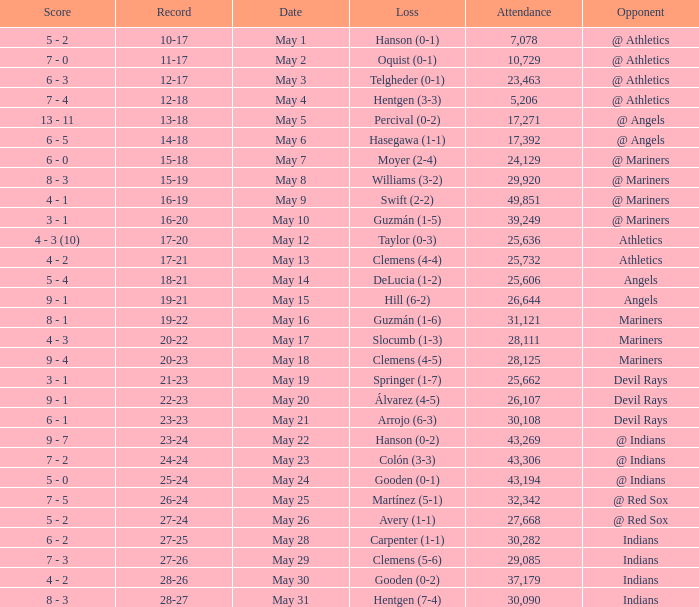Parse the full table. {'header': ['Score', 'Record', 'Date', 'Loss', 'Attendance', 'Opponent'], 'rows': [['5 - 2', '10-17', 'May 1', 'Hanson (0-1)', '7,078', '@ Athletics'], ['7 - 0', '11-17', 'May 2', 'Oquist (0-1)', '10,729', '@ Athletics'], ['6 - 3', '12-17', 'May 3', 'Telgheder (0-1)', '23,463', '@ Athletics'], ['7 - 4', '12-18', 'May 4', 'Hentgen (3-3)', '5,206', '@ Athletics'], ['13 - 11', '13-18', 'May 5', 'Percival (0-2)', '17,271', '@ Angels'], ['6 - 5', '14-18', 'May 6', 'Hasegawa (1-1)', '17,392', '@ Angels'], ['6 - 0', '15-18', 'May 7', 'Moyer (2-4)', '24,129', '@ Mariners'], ['8 - 3', '15-19', 'May 8', 'Williams (3-2)', '29,920', '@ Mariners'], ['4 - 1', '16-19', 'May 9', 'Swift (2-2)', '49,851', '@ Mariners'], ['3 - 1', '16-20', 'May 10', 'Guzmán (1-5)', '39,249', '@ Mariners'], ['4 - 3 (10)', '17-20', 'May 12', 'Taylor (0-3)', '25,636', 'Athletics'], ['4 - 2', '17-21', 'May 13', 'Clemens (4-4)', '25,732', 'Athletics'], ['5 - 4', '18-21', 'May 14', 'DeLucia (1-2)', '25,606', 'Angels'], ['9 - 1', '19-21', 'May 15', 'Hill (6-2)', '26,644', 'Angels'], ['8 - 1', '19-22', 'May 16', 'Guzmán (1-6)', '31,121', 'Mariners'], ['4 - 3', '20-22', 'May 17', 'Slocumb (1-3)', '28,111', 'Mariners'], ['9 - 4', '20-23', 'May 18', 'Clemens (4-5)', '28,125', 'Mariners'], ['3 - 1', '21-23', 'May 19', 'Springer (1-7)', '25,662', 'Devil Rays'], ['9 - 1', '22-23', 'May 20', 'Álvarez (4-5)', '26,107', 'Devil Rays'], ['6 - 1', '23-23', 'May 21', 'Arrojo (6-3)', '30,108', 'Devil Rays'], ['9 - 7', '23-24', 'May 22', 'Hanson (0-2)', '43,269', '@ Indians'], ['7 - 2', '24-24', 'May 23', 'Colón (3-3)', '43,306', '@ Indians'], ['5 - 0', '25-24', 'May 24', 'Gooden (0-1)', '43,194', '@ Indians'], ['7 - 5', '26-24', 'May 25', 'Martínez (5-1)', '32,342', '@ Red Sox'], ['5 - 2', '27-24', 'May 26', 'Avery (1-1)', '27,668', '@ Red Sox'], ['6 - 2', '27-25', 'May 28', 'Carpenter (1-1)', '30,282', 'Indians'], ['7 - 3', '27-26', 'May 29', 'Clemens (5-6)', '29,085', 'Indians'], ['4 - 2', '28-26', 'May 30', 'Gooden (0-2)', '37,179', 'Indians'], ['8 - 3', '28-27', 'May 31', 'Hentgen (7-4)', '30,090', 'Indians']]} What is the record for May 31? 28-27. 